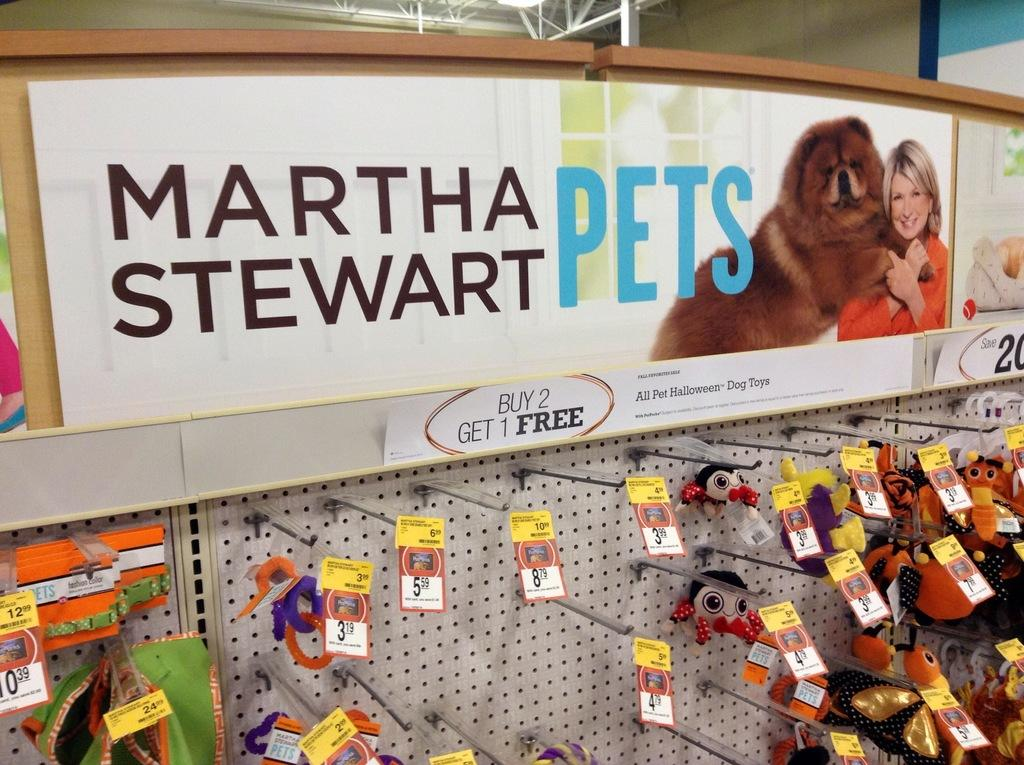What is the main object in the image? There is a board in the image. What is displayed on the top of the board? There are hoardings at the top of the board. What is attached to the board for holding items? Hangers are attached to the board. What can be seen hanging on the hangers? There are items on the hangers. How can the price of the items be identified? Price tags are associated with the items. What can be seen in the background of the image? There are poles and a wall in the background of the image. What type of lead is being used to connect the items on the board? There is no lead present in the image; the items are hanging on hangers. What type of office furniture can be seen in the image? There is no office furniture present in the image; it features a board with hangers and items. 